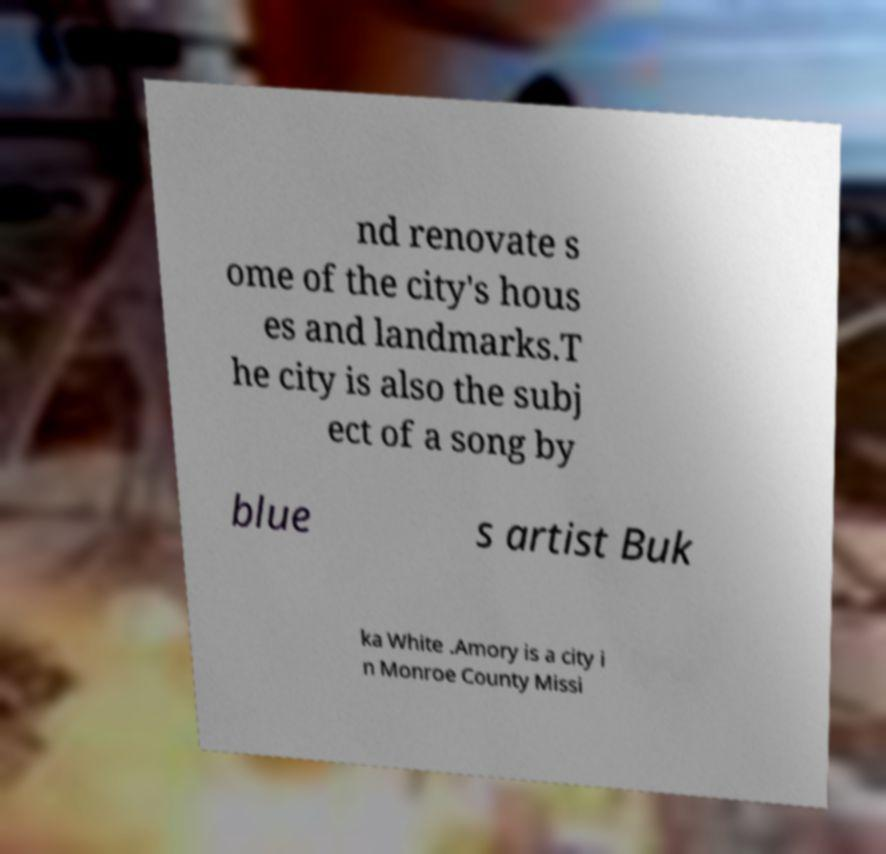There's text embedded in this image that I need extracted. Can you transcribe it verbatim? nd renovate s ome of the city's hous es and landmarks.T he city is also the subj ect of a song by blue s artist Buk ka White .Amory is a city i n Monroe County Missi 